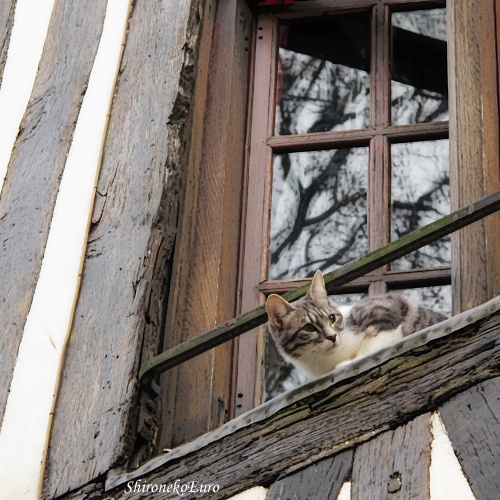Describe the objects in this image and their specific colors. I can see a cat in darkgray, gray, and black tones in this image. 